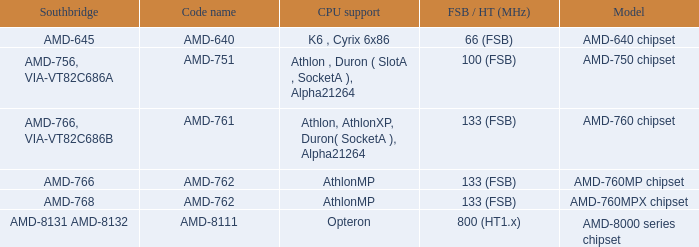What is the Southbridge when the CPU support was athlon, athlonxp, duron( socketa ), alpha21264? AMD-766, VIA-VT82C686B. 